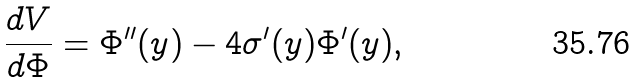<formula> <loc_0><loc_0><loc_500><loc_500>\frac { d V } { d \Phi } = \Phi ^ { \prime \prime } ( y ) - 4 \sigma ^ { \prime } ( y ) \Phi ^ { \prime } ( y ) ,</formula> 